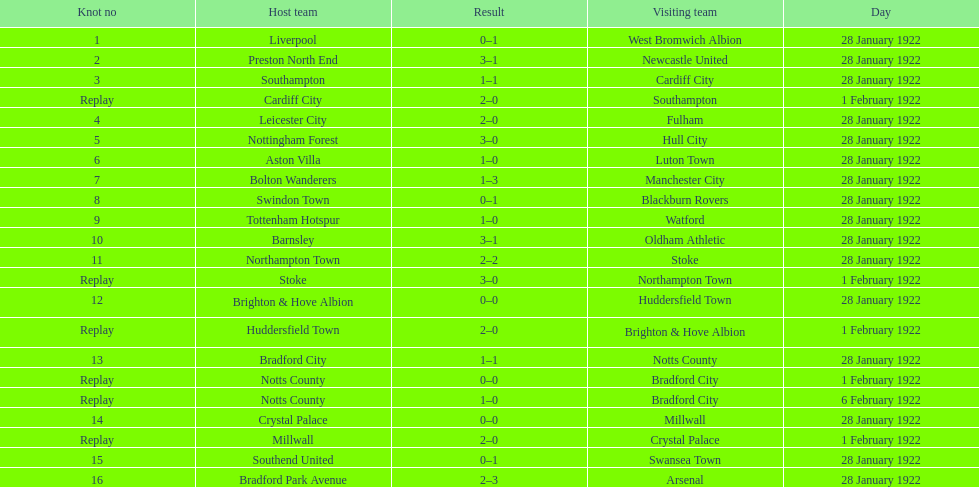Who is the first home team listed as having a score of 3-1? Preston North End. 